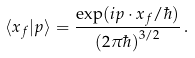<formula> <loc_0><loc_0><loc_500><loc_500>\langle { x } _ { f } | { p } \rangle = \frac { \exp ( i { p } \cdot { x } _ { f } / \hbar { ) } } { ( 2 \pi \hbar { ) } ^ { 3 / 2 } } \, .</formula> 